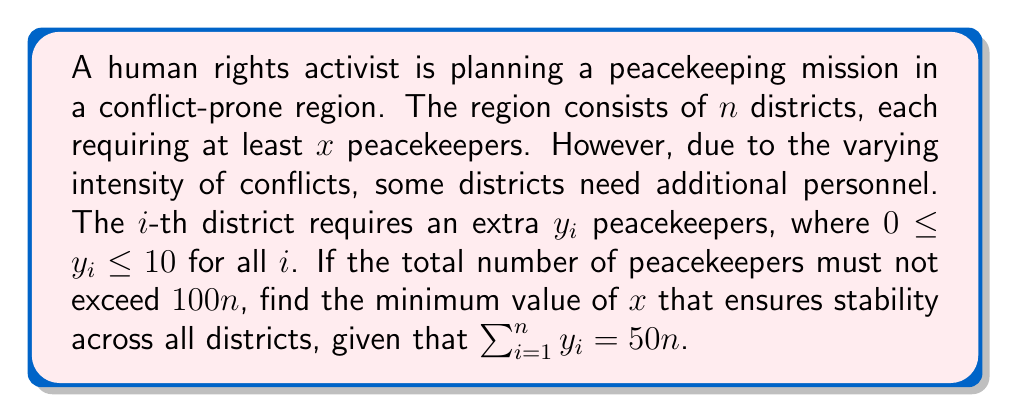Solve this math problem. Let's approach this step-by-step:

1) For each district, the number of peacekeepers needed is $x + y_i$.

2) The total number of peacekeepers for all districts is:

   $$\sum_{i=1}^n (x + y_i) = nx + \sum_{i=1}^n y_i$$

3) We're given that $\sum_{i=1}^n y_i = 50n$, so we can substitute this:

   $$nx + 50n$$

4) This total must not exceed $100n$:

   $$nx + 50n \leq 100n$$

5) Simplifying:

   $$nx \leq 50n$$
   $$x \leq 50$$

6) However, we need to find the minimum value of $x$. Since $x$ represents the base number of peacekeepers per district, it must be an integer.

7) Additionally, we need to ensure that $x + y_i \leq 100$ for all districts, even for the district with the maximum $y_i$ (which is 10).

8) Therefore:

   $$x + 10 \leq 100$$
   $$x \leq 90$$

9) Combining conditions from steps 5 and 8, we need the largest integer $x$ such that $x \leq 50$.
Answer: $x = 50$ 